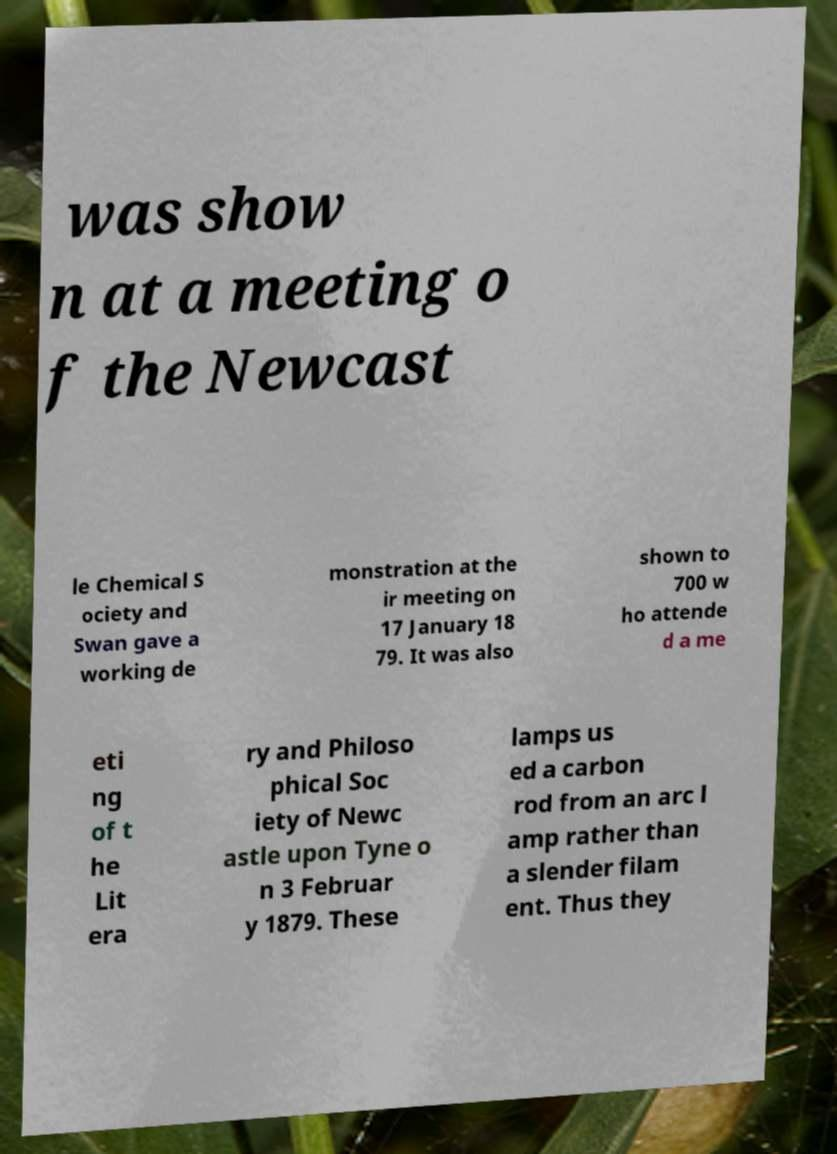Please read and relay the text visible in this image. What does it say? was show n at a meeting o f the Newcast le Chemical S ociety and Swan gave a working de monstration at the ir meeting on 17 January 18 79. It was also shown to 700 w ho attende d a me eti ng of t he Lit era ry and Philoso phical Soc iety of Newc astle upon Tyne o n 3 Februar y 1879. These lamps us ed a carbon rod from an arc l amp rather than a slender filam ent. Thus they 